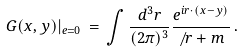<formula> <loc_0><loc_0><loc_500><loc_500>G ( x , y ) | _ { e = 0 } \, = \, \int \frac { d ^ { 3 } r } { ( 2 \pi ) ^ { 3 } } \frac { e ^ { i r \cdot ( x - y ) } } { \not \, r + m } \, .</formula> 